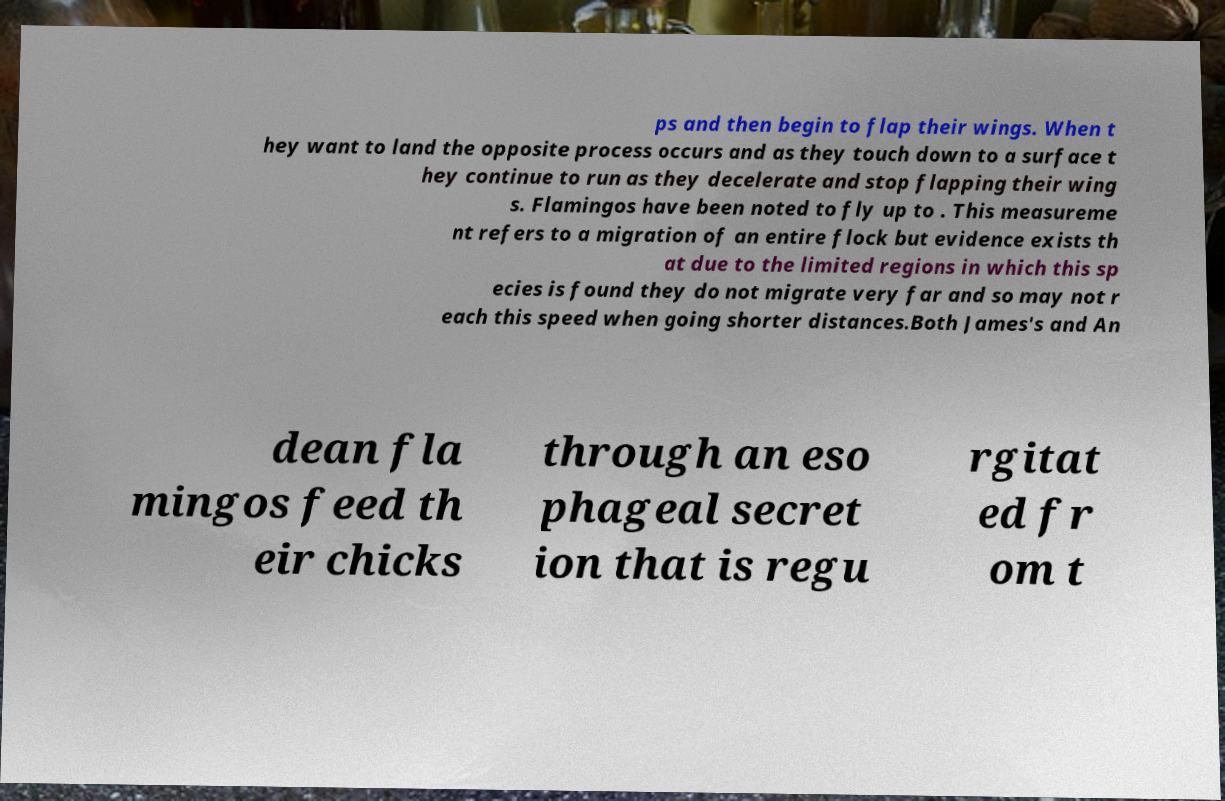Can you read and provide the text displayed in the image?This photo seems to have some interesting text. Can you extract and type it out for me? ps and then begin to flap their wings. When t hey want to land the opposite process occurs and as they touch down to a surface t hey continue to run as they decelerate and stop flapping their wing s. Flamingos have been noted to fly up to . This measureme nt refers to a migration of an entire flock but evidence exists th at due to the limited regions in which this sp ecies is found they do not migrate very far and so may not r each this speed when going shorter distances.Both James's and An dean fla mingos feed th eir chicks through an eso phageal secret ion that is regu rgitat ed fr om t 